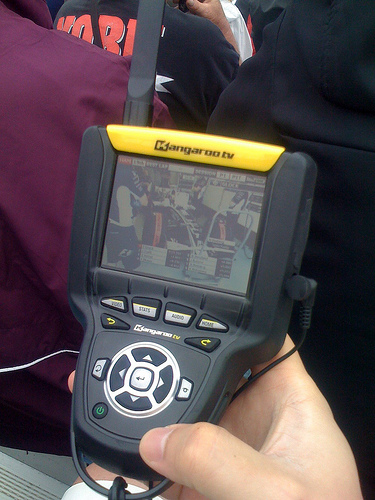<image>
Is there a game above the man? No. The game is not positioned above the man. The vertical arrangement shows a different relationship. 